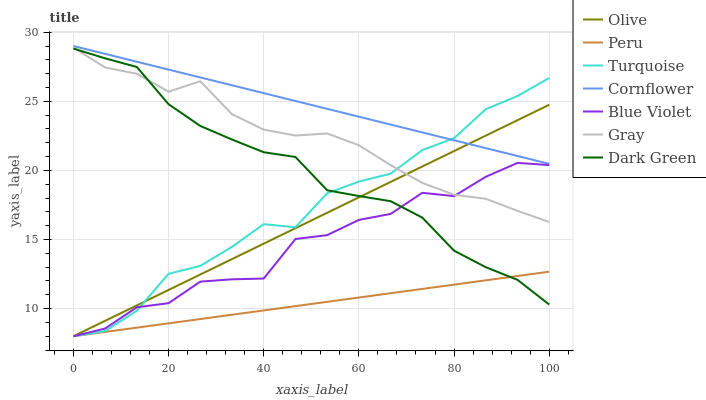Does Peru have the minimum area under the curve?
Answer yes or no. Yes. Does Cornflower have the maximum area under the curve?
Answer yes or no. Yes. Does Turquoise have the minimum area under the curve?
Answer yes or no. No. Does Turquoise have the maximum area under the curve?
Answer yes or no. No. Is Peru the smoothest?
Answer yes or no. Yes. Is Blue Violet the roughest?
Answer yes or no. Yes. Is Turquoise the smoothest?
Answer yes or no. No. Is Turquoise the roughest?
Answer yes or no. No. Does Turquoise have the lowest value?
Answer yes or no. Yes. Does Gray have the lowest value?
Answer yes or no. No. Does Cornflower have the highest value?
Answer yes or no. Yes. Does Turquoise have the highest value?
Answer yes or no. No. Is Gray less than Cornflower?
Answer yes or no. Yes. Is Gray greater than Peru?
Answer yes or no. Yes. Does Peru intersect Olive?
Answer yes or no. Yes. Is Peru less than Olive?
Answer yes or no. No. Is Peru greater than Olive?
Answer yes or no. No. Does Gray intersect Cornflower?
Answer yes or no. No. 